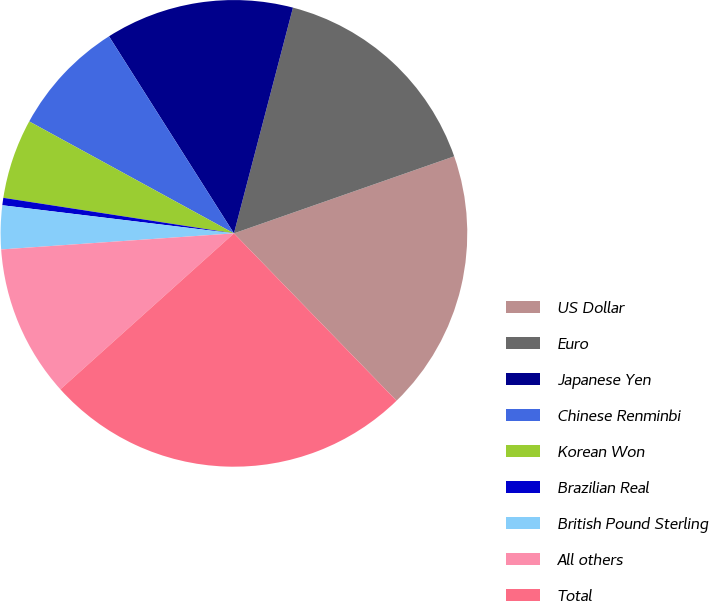<chart> <loc_0><loc_0><loc_500><loc_500><pie_chart><fcel>US Dollar<fcel>Euro<fcel>Japanese Yen<fcel>Chinese Renminbi<fcel>Korean Won<fcel>Brazilian Real<fcel>British Pound Sterling<fcel>All others<fcel>Total<nl><fcel>18.08%<fcel>15.57%<fcel>13.06%<fcel>8.04%<fcel>5.53%<fcel>0.51%<fcel>3.02%<fcel>10.55%<fcel>25.61%<nl></chart> 